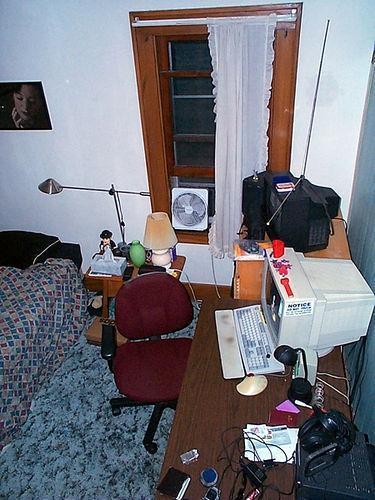How many chairs in the room?
Give a very brief answer. 1. How many tvs can be seen?
Give a very brief answer. 2. How many bike on this image?
Give a very brief answer. 0. 